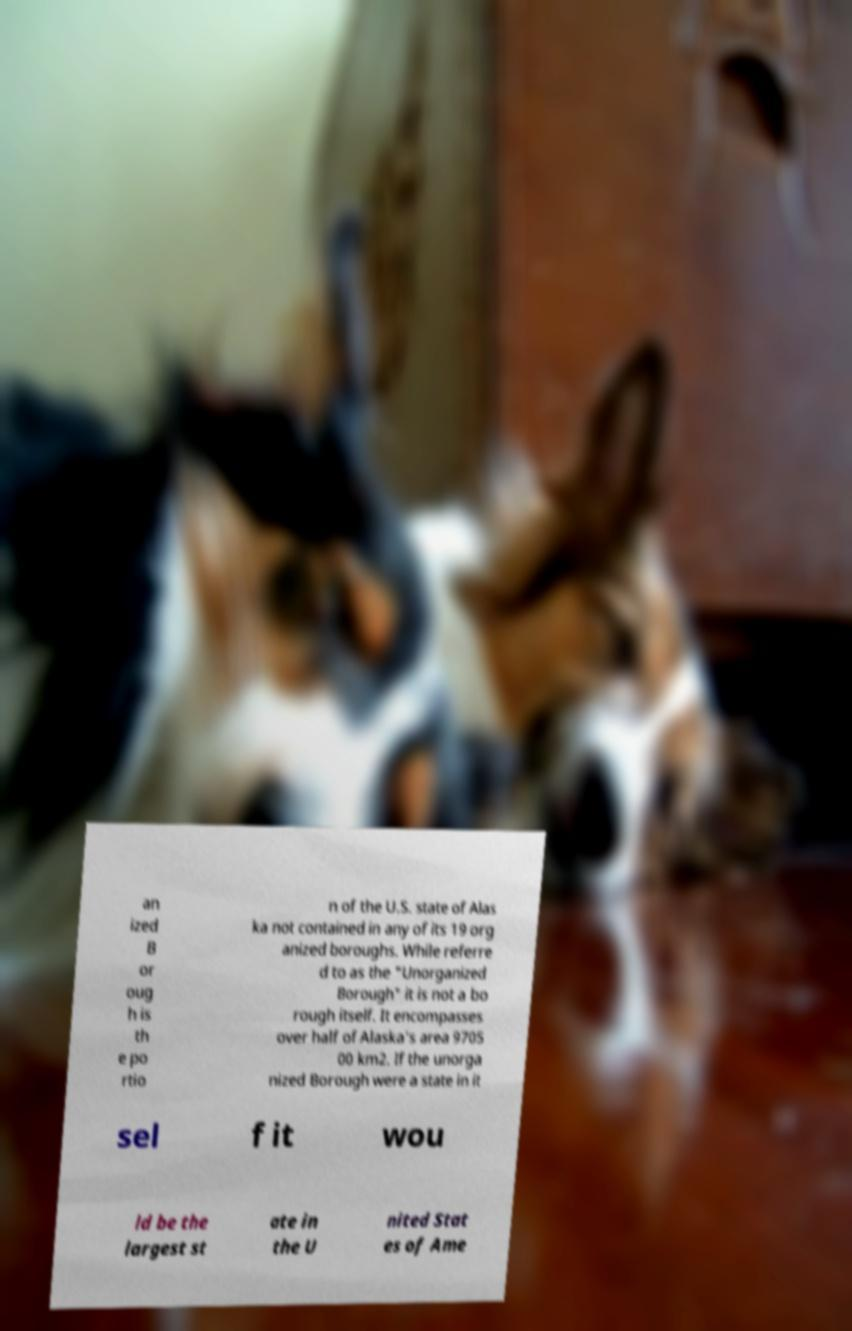Can you read and provide the text displayed in the image?This photo seems to have some interesting text. Can you extract and type it out for me? an ized B or oug h is th e po rtio n of the U.S. state of Alas ka not contained in any of its 19 org anized boroughs. While referre d to as the "Unorganized Borough" it is not a bo rough itself. It encompasses over half of Alaska's area 9705 00 km2. If the unorga nized Borough were a state in it sel f it wou ld be the largest st ate in the U nited Stat es of Ame 